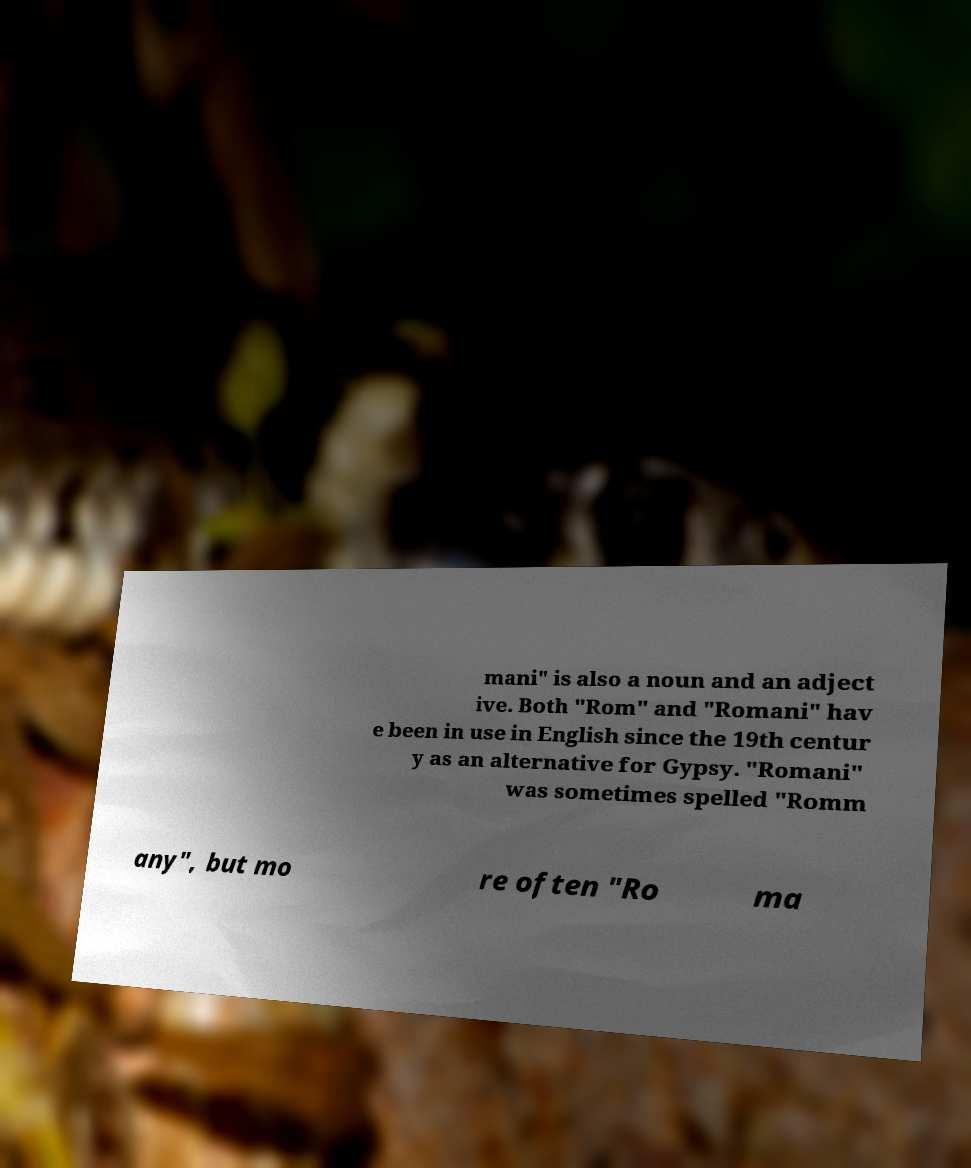Could you assist in decoding the text presented in this image and type it out clearly? mani" is also a noun and an adject ive. Both "Rom" and "Romani" hav e been in use in English since the 19th centur y as an alternative for Gypsy. "Romani" was sometimes spelled "Romm any", but mo re often "Ro ma 